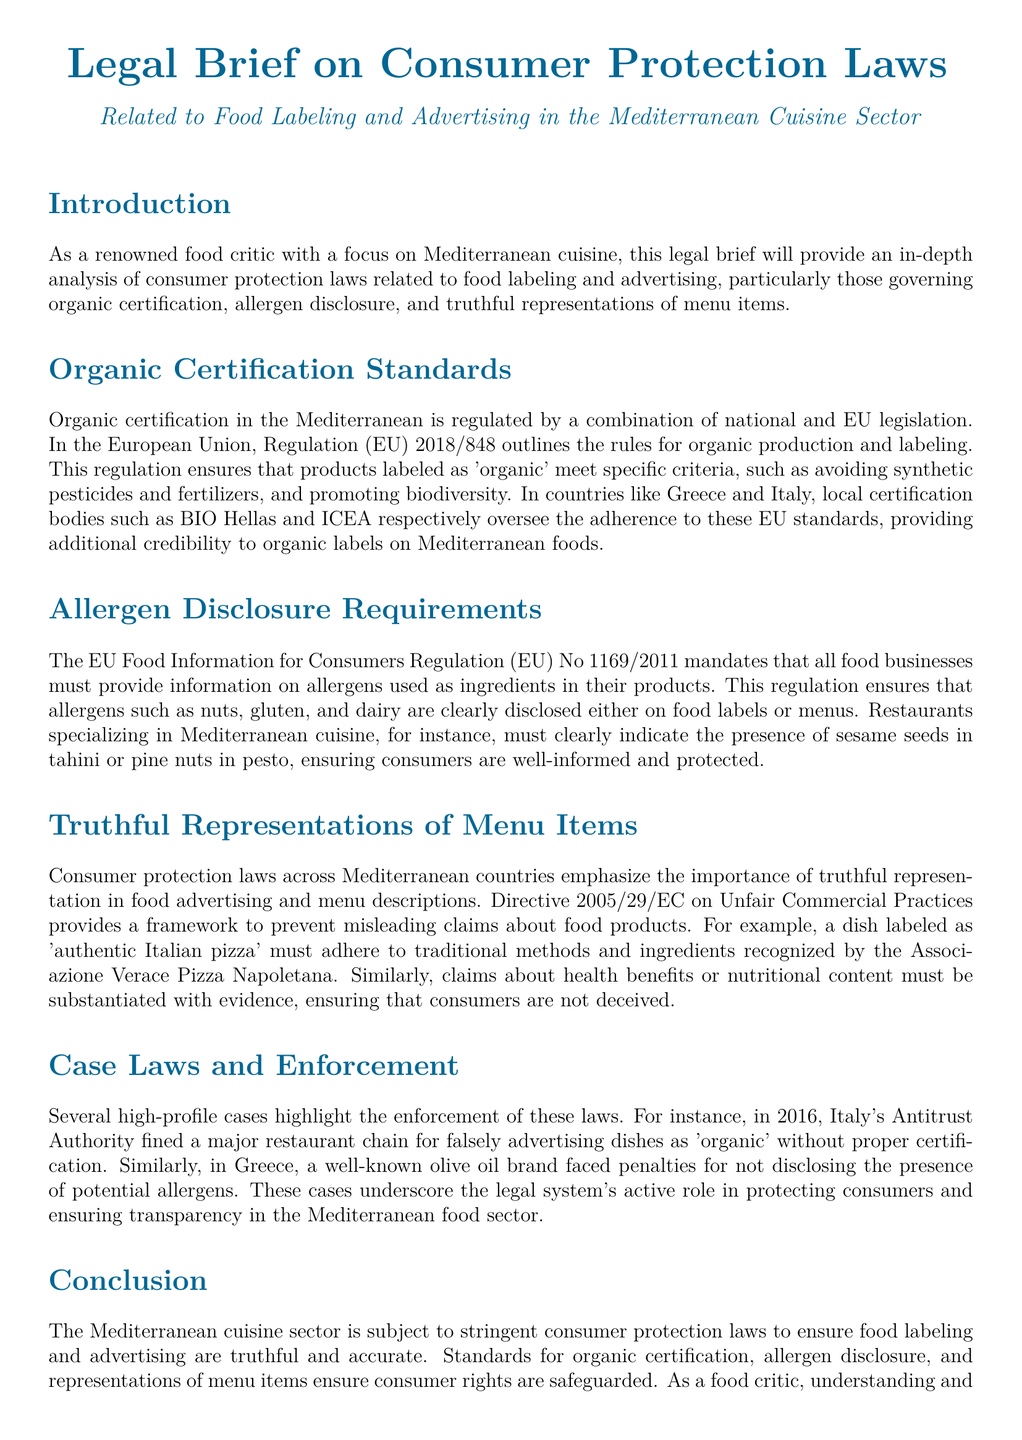What regulation outlines the rules for organic production in the EU? The document states that Regulation (EU) 2018/848 outlines the rules for organic production and labeling.
Answer: Regulation (EU) 2018/848 Which certification body oversees organic standards in Greece? According to the document, BIO Hellas is the local certification body in Greece for organic standards.
Answer: BIO Hellas What must restaurants disclose about allergens? The document mentions that food businesses must provide information on allergens used as ingredients.
Answer: Allergens used as ingredients What directive prevents misleading claims about food products? The document states that Directive 2005/29/EC on Unfair Commercial Practices provides a framework for preventing misleading claims.
Answer: Directive 2005/29/EC In what year was a restaurant chain fined for falsely advertising organic dishes in Italy? The document notes that in 2016, Italy's Antitrust Authority fined a restaurant chain for false advertising.
Answer: 2016 What is one example of a dish that must adhere to traditional methods according to the document? The document provides the example of 'authentic Italian pizza' needing to adhere to traditional methods.
Answer: Authentic Italian pizza How does the document categorize consumer protection laws related to labeling? The legal brief categorizes consumer protection laws as ensuring food labeling and advertising are truthful and accurate.
Answer: Truthful and accurate What is a requirement for health claims made about food products? The document states that claims about health benefits must be substantiated with evidence.
Answer: Substantiated with evidence Who faced penalties for not disclosing allergens in Greece? The document mentions that a well-known olive oil brand faced penalties for not disclosing allergens.
Answer: A well-known olive oil brand 